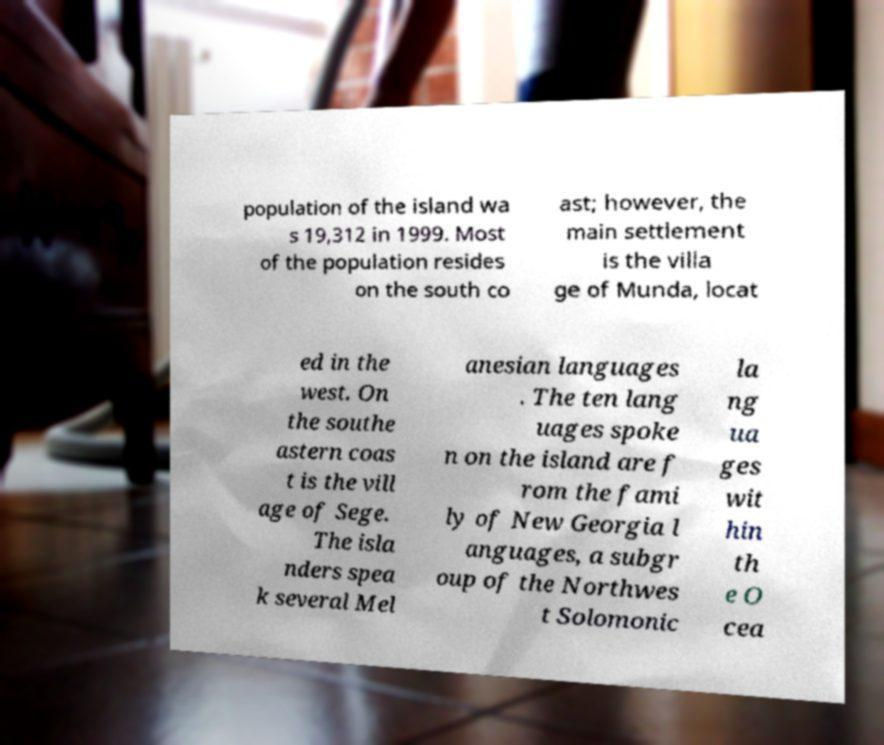Could you assist in decoding the text presented in this image and type it out clearly? population of the island wa s 19,312 in 1999. Most of the population resides on the south co ast; however, the main settlement is the villa ge of Munda, locat ed in the west. On the southe astern coas t is the vill age of Sege. The isla nders spea k several Mel anesian languages . The ten lang uages spoke n on the island are f rom the fami ly of New Georgia l anguages, a subgr oup of the Northwes t Solomonic la ng ua ges wit hin th e O cea 